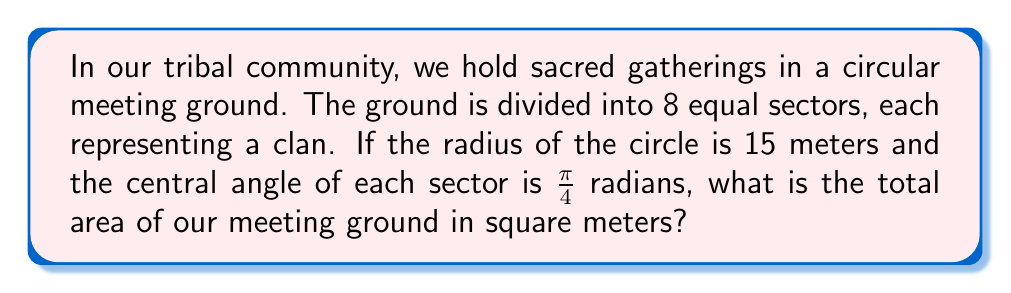Teach me how to tackle this problem. Let's approach this step-by-step:

1) The area of a circle is given by the formula:
   $$A = \pi r^2$$
   where $r$ is the radius.

2) We are given that the radius is 15 meters, so we can substitute this:
   $$A = \pi (15)^2 = 225\pi$$

3) However, we can also solve this using trigonometry. The area of a sector of a circle is given by:
   $$A_{sector} = \frac{1}{2} r^2 \theta$$
   where $\theta$ is the central angle in radians.

4) We're told that there are 8 equal sectors, each with a central angle of $\frac{\pi}{4}$ radians.

5) The area of one sector is:
   $$A_{sector} = \frac{1}{2} (15)^2 \cdot \frac{\pi}{4} = \frac{225\pi}{8}$$

6) Since there are 8 sectors, we multiply this by 8:
   $$A_{total} = 8 \cdot \frac{225\pi}{8} = 225\pi$$

7) This confirms our result from step 2.

8) To get the final answer in square meters, we need to evaluate $225\pi$:
   $$225\pi \approx 706.86 \text{ m}^2$$
Answer: $706.86 \text{ m}^2$ 